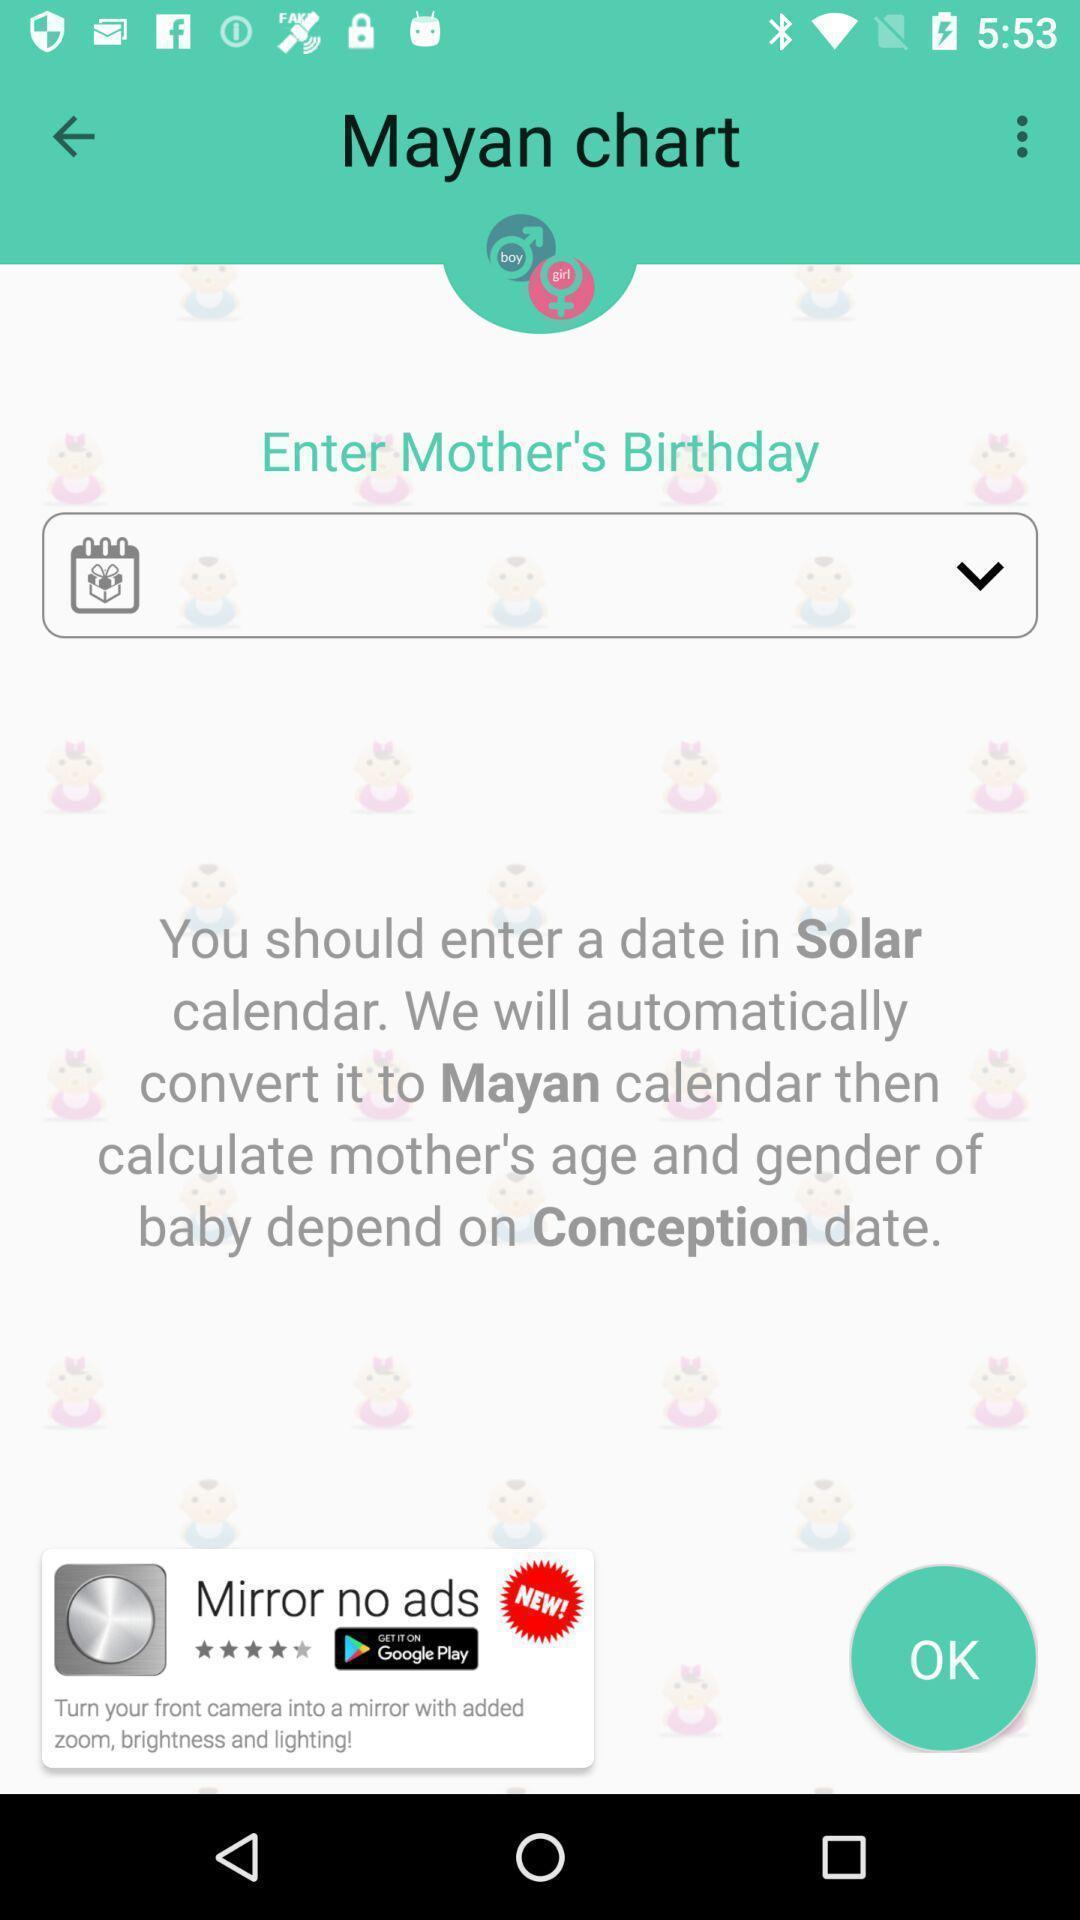Please provide a description for this image. Page requesting to add date of birth. 